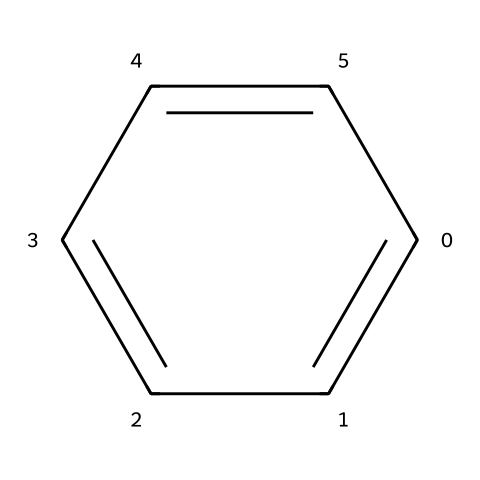What is the name of this chemical? The chemical structure corresponds to a six-carbon ring with alternating double bonds, which is characteristic of benzene.
Answer: benzene How many carbon atoms are present in this molecule? Analyzing the SMILES representation indicates there are six 'c' characters, each representing a carbon atom in the benzene ring.
Answer: six What is the degree of saturation of this hydrocarbon? Benzene is fully saturated with respect to hydrogen due to its structure, having six carbon atoms and six hydrogen atoms, which corresponds to a degree of saturation of six.
Answer: six How many hydrogen atoms are in benzene? For every carbon atom in benzene, there is one hydrogen atom attached, leading to a total of six hydrogen atoms for the six carbons.
Answer: six Is benzene an aromatic compound? Benzene includes a cyclic structure with resonance stabilization, fitting the criteria of aromatic compounds, which hold special stability due to electron delocalization.
Answer: yes What type of bonds are present between the carbon atoms in benzene? The structure of benzene consists of alternating single and double bonds, creating a resonance hybrid which gives it unique bonding characteristics.
Answer: alternating single and double bonds 